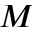<formula> <loc_0><loc_0><loc_500><loc_500>M</formula> 